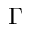Convert formula to latex. <formula><loc_0><loc_0><loc_500><loc_500>\Gamma</formula> 